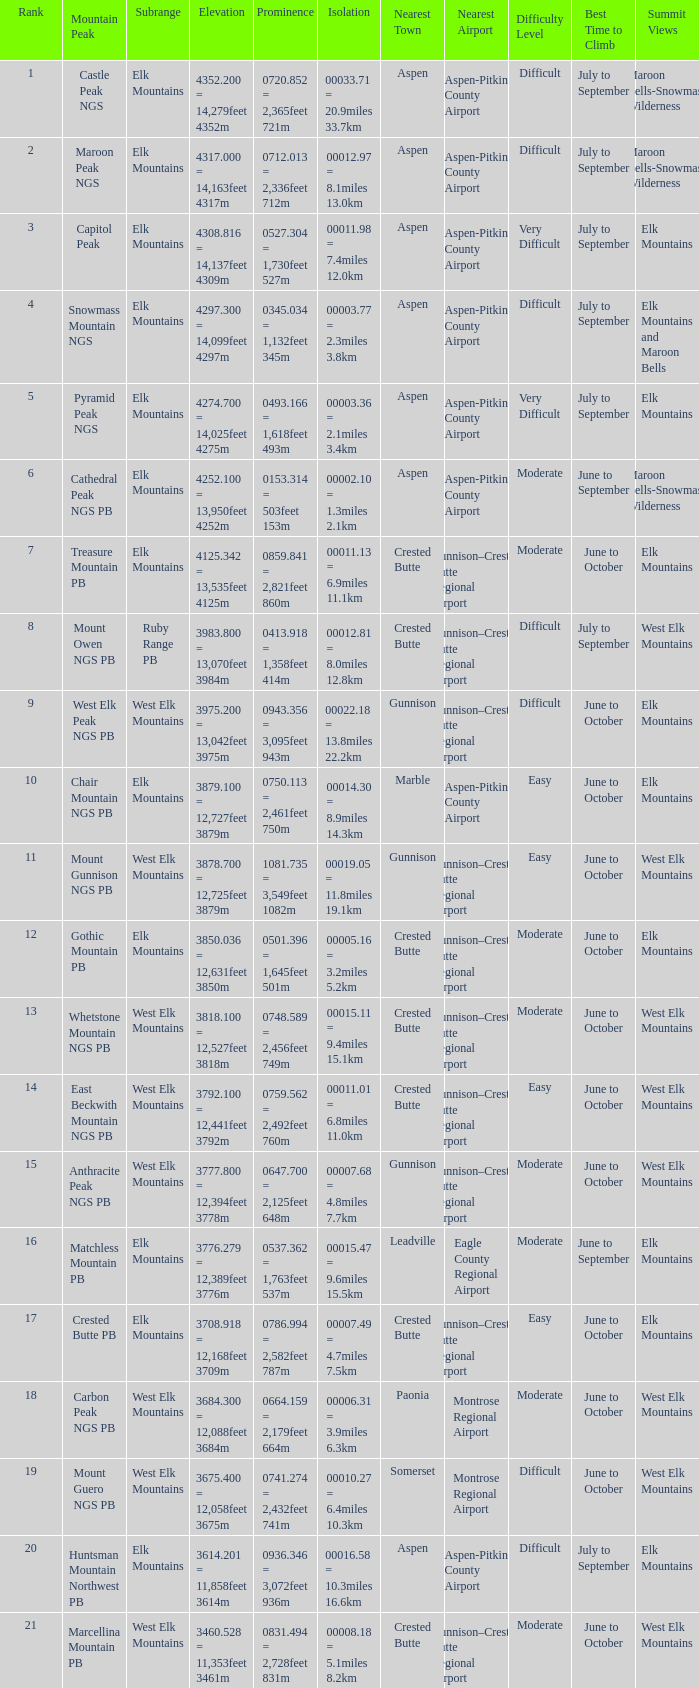Could you parse the entire table? {'header': ['Rank', 'Mountain Peak', 'Subrange', 'Elevation', 'Prominence', 'Isolation', 'Nearest Town', 'Nearest Airport', 'Difficulty Level', 'Best Time to Climb', 'Summit Views'], 'rows': [['1', 'Castle Peak NGS', 'Elk Mountains', '4352.200 = 14,279feet 4352m', '0720.852 = 2,365feet 721m', '00033.71 = 20.9miles 33.7km', 'Aspen', 'Aspen-Pitkin County Airport', 'Difficult', 'July to September', 'Maroon Bells-Snowmass Wilderness'], ['2', 'Maroon Peak NGS', 'Elk Mountains', '4317.000 = 14,163feet 4317m', '0712.013 = 2,336feet 712m', '00012.97 = 8.1miles 13.0km', 'Aspen', 'Aspen-Pitkin County Airport', 'Difficult', 'July to September', 'Maroon Bells-Snowmass Wilderness'], ['3', 'Capitol Peak', 'Elk Mountains', '4308.816 = 14,137feet 4309m', '0527.304 = 1,730feet 527m', '00011.98 = 7.4miles 12.0km', 'Aspen', 'Aspen-Pitkin County Airport', 'Very Difficult', 'July to September', 'Elk Mountains'], ['4', 'Snowmass Mountain NGS', 'Elk Mountains', '4297.300 = 14,099feet 4297m', '0345.034 = 1,132feet 345m', '00003.77 = 2.3miles 3.8km', 'Aspen', 'Aspen-Pitkin County Airport', 'Difficult', 'July to September', 'Elk Mountains and Maroon Bells'], ['5', 'Pyramid Peak NGS', 'Elk Mountains', '4274.700 = 14,025feet 4275m', '0493.166 = 1,618feet 493m', '00003.36 = 2.1miles 3.4km', 'Aspen', 'Aspen-Pitkin County Airport', 'Very Difficult', 'July to September', 'Elk Mountains'], ['6', 'Cathedral Peak NGS PB', 'Elk Mountains', '4252.100 = 13,950feet 4252m', '0153.314 = 503feet 153m', '00002.10 = 1.3miles 2.1km', 'Aspen', 'Aspen-Pitkin County Airport', 'Moderate', 'June to September', 'Maroon Bells-Snowmass Wilderness'], ['7', 'Treasure Mountain PB', 'Elk Mountains', '4125.342 = 13,535feet 4125m', '0859.841 = 2,821feet 860m', '00011.13 = 6.9miles 11.1km', 'Crested Butte', 'Gunnison–Crested Butte Regional Airport', 'Moderate', 'June to October', 'Elk Mountains'], ['8', 'Mount Owen NGS PB', 'Ruby Range PB', '3983.800 = 13,070feet 3984m', '0413.918 = 1,358feet 414m', '00012.81 = 8.0miles 12.8km', 'Crested Butte', 'Gunnison–Crested Butte Regional Airport', 'Difficult', 'July to September', 'West Elk Mountains'], ['9', 'West Elk Peak NGS PB', 'West Elk Mountains', '3975.200 = 13,042feet 3975m', '0943.356 = 3,095feet 943m', '00022.18 = 13.8miles 22.2km', 'Gunnison', 'Gunnison–Crested Butte Regional Airport', 'Difficult', 'June to October', 'Elk Mountains'], ['10', 'Chair Mountain NGS PB', 'Elk Mountains', '3879.100 = 12,727feet 3879m', '0750.113 = 2,461feet 750m', '00014.30 = 8.9miles 14.3km', 'Marble', 'Aspen-Pitkin County Airport', 'Easy', 'June to October', 'Elk Mountains'], ['11', 'Mount Gunnison NGS PB', 'West Elk Mountains', '3878.700 = 12,725feet 3879m', '1081.735 = 3,549feet 1082m', '00019.05 = 11.8miles 19.1km', 'Gunnison', 'Gunnison–Crested Butte Regional Airport', 'Easy', 'June to October', 'West Elk Mountains'], ['12', 'Gothic Mountain PB', 'Elk Mountains', '3850.036 = 12,631feet 3850m', '0501.396 = 1,645feet 501m', '00005.16 = 3.2miles 5.2km', 'Crested Butte', 'Gunnison–Crested Butte Regional Airport', 'Moderate', 'June to October', 'Elk Mountains'], ['13', 'Whetstone Mountain NGS PB', 'West Elk Mountains', '3818.100 = 12,527feet 3818m', '0748.589 = 2,456feet 749m', '00015.11 = 9.4miles 15.1km', 'Crested Butte', 'Gunnison–Crested Butte Regional Airport', 'Moderate', 'June to October', 'West Elk Mountains'], ['14', 'East Beckwith Mountain NGS PB', 'West Elk Mountains', '3792.100 = 12,441feet 3792m', '0759.562 = 2,492feet 760m', '00011.01 = 6.8miles 11.0km', 'Crested Butte', 'Gunnison–Crested Butte Regional Airport', 'Easy', 'June to October', 'West Elk Mountains'], ['15', 'Anthracite Peak NGS PB', 'West Elk Mountains', '3777.800 = 12,394feet 3778m', '0647.700 = 2,125feet 648m', '00007.68 = 4.8miles 7.7km', 'Gunnison', 'Gunnison–Crested Butte Regional Airport', 'Moderate', 'June to October', 'West Elk Mountains'], ['16', 'Matchless Mountain PB', 'Elk Mountains', '3776.279 = 12,389feet 3776m', '0537.362 = 1,763feet 537m', '00015.47 = 9.6miles 15.5km', 'Leadville', 'Eagle County Regional Airport', 'Moderate', 'June to September', 'Elk Mountains'], ['17', 'Crested Butte PB', 'Elk Mountains', '3708.918 = 12,168feet 3709m', '0786.994 = 2,582feet 787m', '00007.49 = 4.7miles 7.5km', 'Crested Butte', 'Gunnison–Crested Butte Regional Airport', 'Easy', 'June to October', 'Elk Mountains'], ['18', 'Carbon Peak NGS PB', 'West Elk Mountains', '3684.300 = 12,088feet 3684m', '0664.159 = 2,179feet 664m', '00006.31 = 3.9miles 6.3km', 'Paonia', 'Montrose Regional Airport', 'Moderate', 'June to October', 'West Elk Mountains'], ['19', 'Mount Guero NGS PB', 'West Elk Mountains', '3675.400 = 12,058feet 3675m', '0741.274 = 2,432feet 741m', '00010.27 = 6.4miles 10.3km', 'Somerset', 'Montrose Regional Airport', 'Difficult', 'June to October', 'West Elk Mountains'], ['20', 'Huntsman Mountain Northwest PB', 'Elk Mountains', '3614.201 = 11,858feet 3614m', '0936.346 = 3,072feet 936m', '00016.58 = 10.3miles 16.6km', 'Aspen', 'Aspen-Pitkin County Airport', 'Difficult', 'July to September', 'Elk Mountains'], ['21', 'Marcellina Mountain PB', 'West Elk Mountains', '3460.528 = 11,353feet 3461m', '0831.494 = 2,728feet 831m', '00008.18 = 5.1miles 8.2km', 'Crested Butte', 'Gunnison–Crested Butte Regional Airport', 'Moderate', 'June to October', 'West Elk Mountains']]} Name the Prominence of the Mountain Peak of matchless mountain pb? 0537.362 = 1,763feet 537m. 